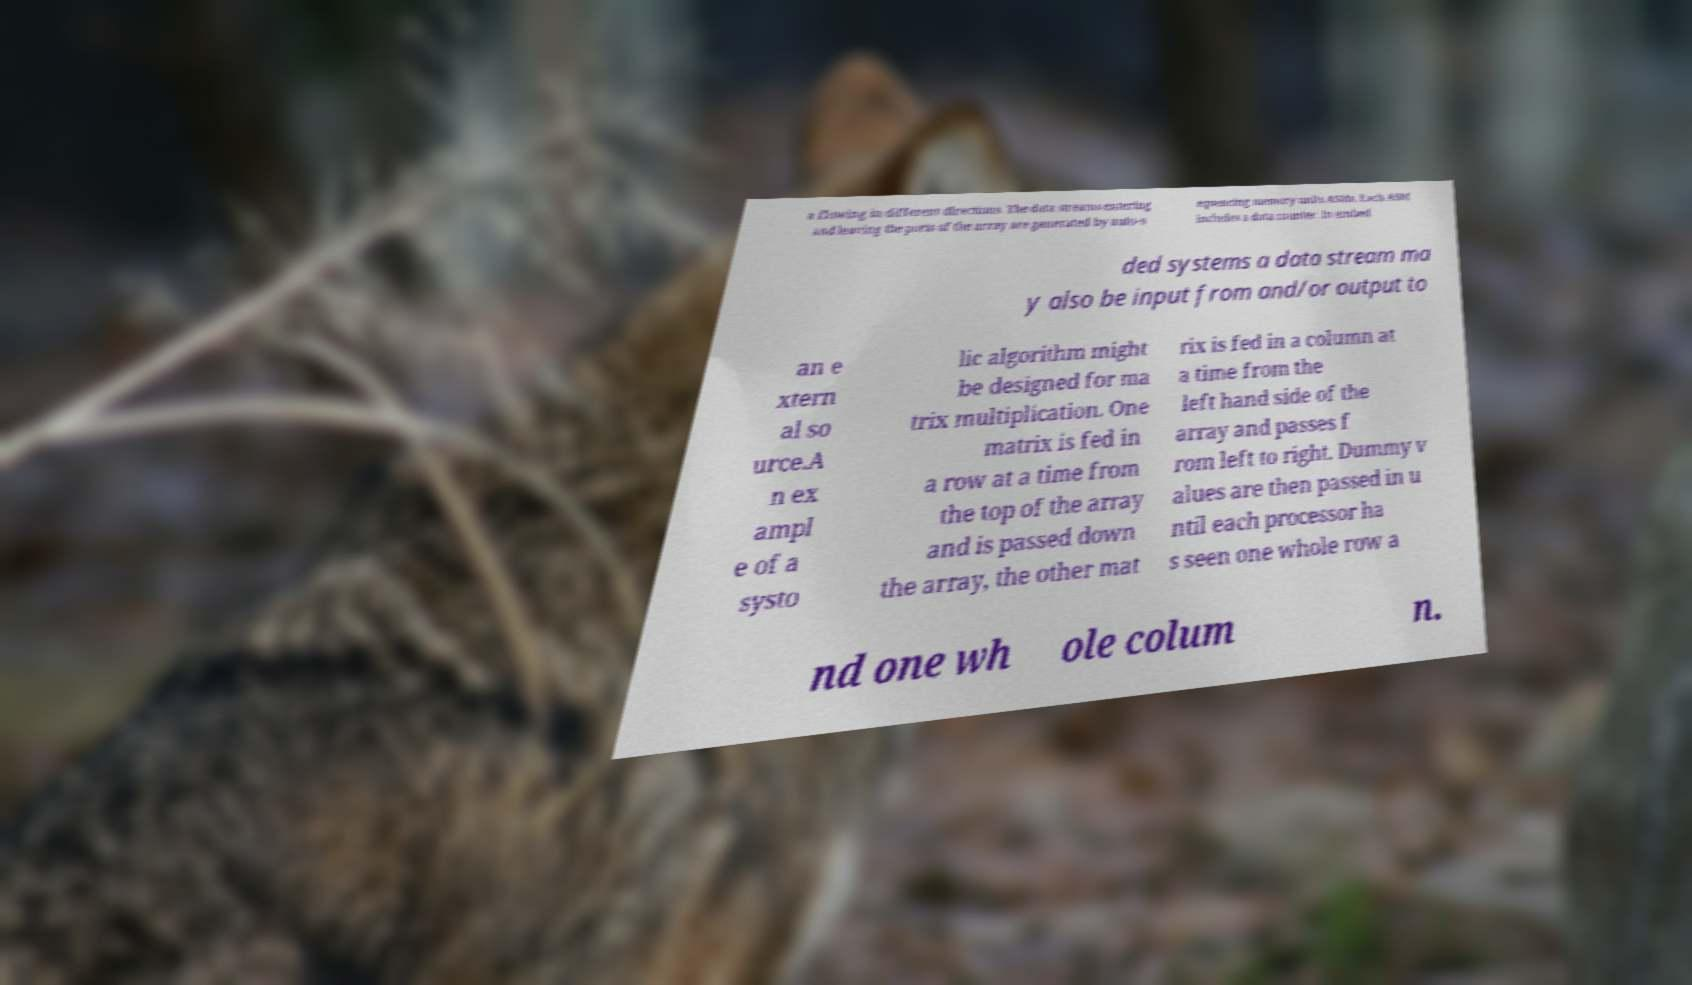What messages or text are displayed in this image? I need them in a readable, typed format. a flowing in different directions. The data streams entering and leaving the ports of the array are generated by auto-s equencing memory units ASMs. Each ASM includes a data counter. In embed ded systems a data stream ma y also be input from and/or output to an e xtern al so urce.A n ex ampl e of a systo lic algorithm might be designed for ma trix multiplication. One matrix is fed in a row at a time from the top of the array and is passed down the array, the other mat rix is fed in a column at a time from the left hand side of the array and passes f rom left to right. Dummy v alues are then passed in u ntil each processor ha s seen one whole row a nd one wh ole colum n. 